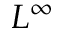Convert formula to latex. <formula><loc_0><loc_0><loc_500><loc_500>L ^ { \infty }</formula> 